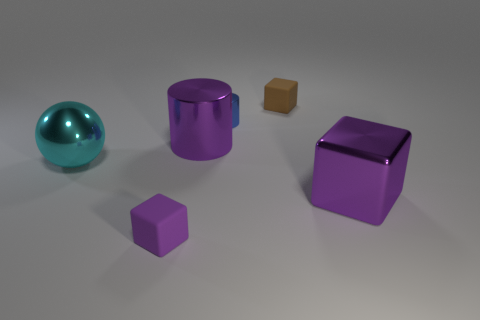There is a tiny object that is the same color as the metallic cube; what is its material?
Offer a very short reply. Rubber. What number of things are either metallic things that are on the right side of the large cyan thing or big metal things behind the cyan metallic object?
Provide a short and direct response. 3. Do the metallic cylinder on the left side of the tiny blue metallic thing and the rubber block in front of the brown rubber thing have the same size?
Provide a short and direct response. No. There is another small object that is the same shape as the brown thing; what color is it?
Ensure brevity in your answer.  Purple. Is there anything else that is the same shape as the large cyan thing?
Provide a short and direct response. No. Is the number of tiny brown rubber things on the right side of the big purple shiny block greater than the number of things on the left side of the small purple matte object?
Your answer should be very brief. No. There is a metal object that is on the left side of the matte object left of the small brown thing right of the metal sphere; what is its size?
Your answer should be very brief. Large. Do the blue cylinder and the large object in front of the cyan thing have the same material?
Provide a succinct answer. Yes. Is the tiny purple rubber thing the same shape as the small blue metallic thing?
Keep it short and to the point. No. What number of other things are there of the same material as the small brown block
Offer a very short reply. 1. 